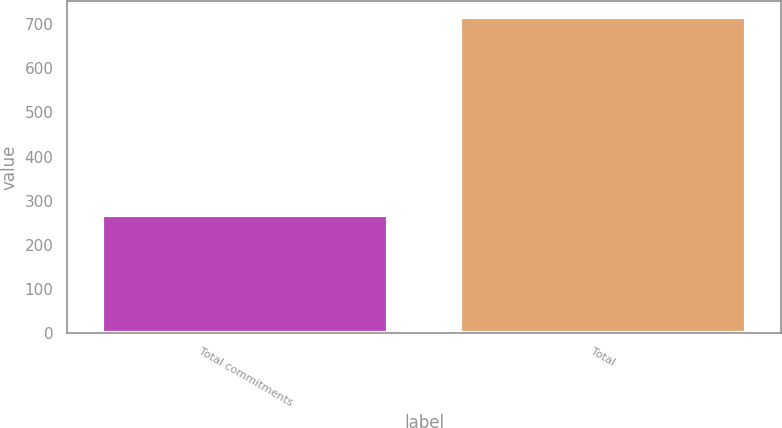<chart> <loc_0><loc_0><loc_500><loc_500><bar_chart><fcel>Total commitments<fcel>Total<nl><fcel>267<fcel>717<nl></chart> 